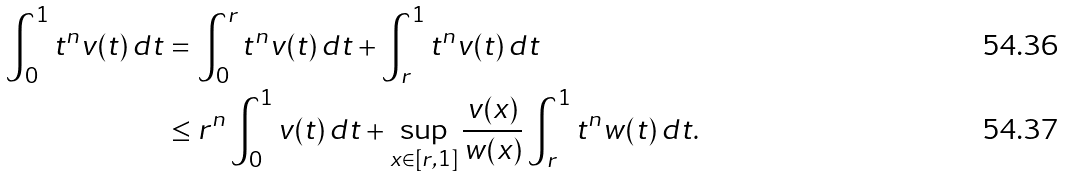<formula> <loc_0><loc_0><loc_500><loc_500>\int _ { 0 } ^ { 1 } t ^ { n } v ( t ) \, d t & = \int _ { 0 } ^ { r } t ^ { n } v ( t ) \, d t + \int _ { r } ^ { 1 } t ^ { n } v ( t ) \, d t \\ & \leq r ^ { n } \int _ { 0 } ^ { 1 } v ( t ) \, d t + \sup _ { x \in [ r , 1 ] } \frac { v ( x ) } { w ( x ) } \int _ { r } ^ { 1 } t ^ { n } w ( t ) \, d t .</formula> 